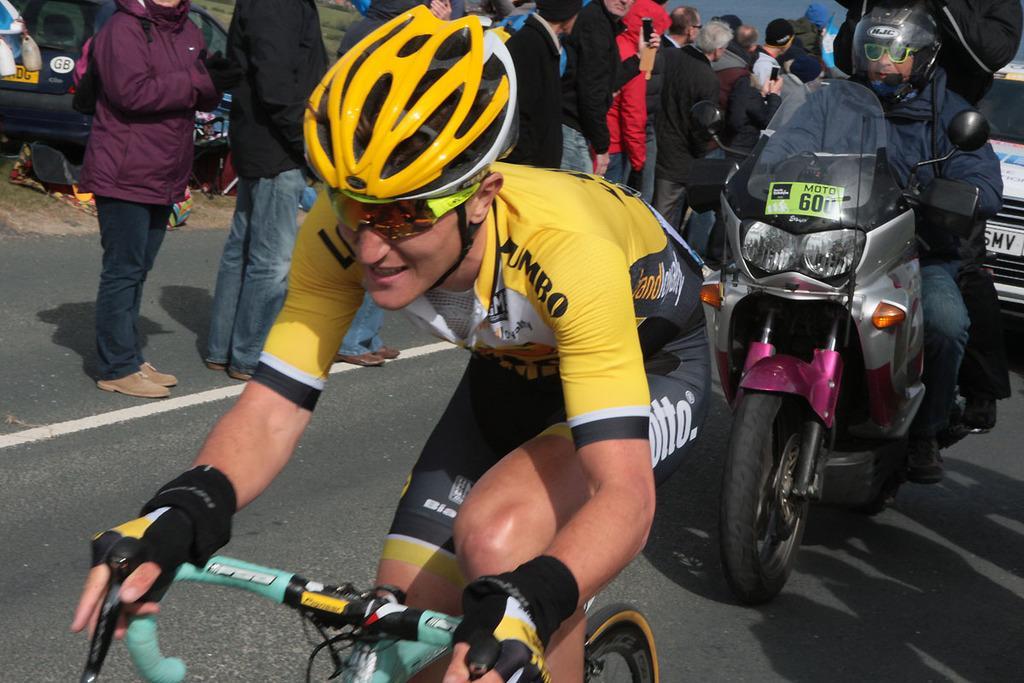Please provide a concise description of this image. In this picture we can see a group of people where some are standing on road and some are riding bicycle and at back of him we have other person riding bike and in the background we can see car and here this person wore helmet, goggle, gloves to hand. 